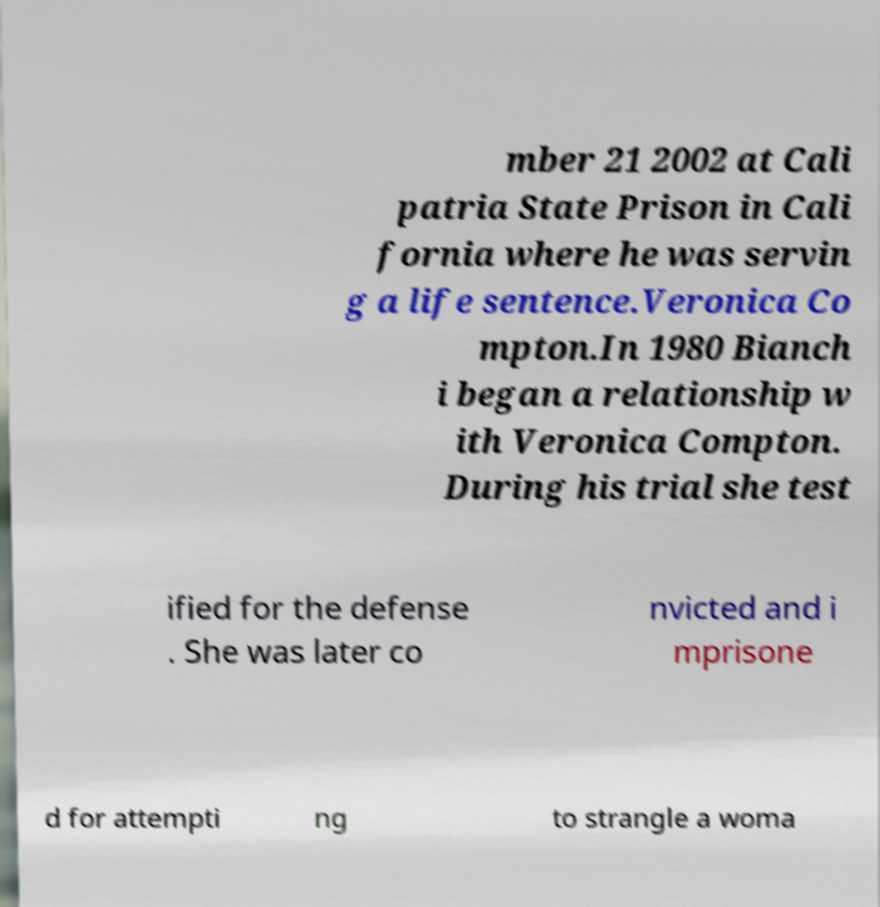What messages or text are displayed in this image? I need them in a readable, typed format. mber 21 2002 at Cali patria State Prison in Cali fornia where he was servin g a life sentence.Veronica Co mpton.In 1980 Bianch i began a relationship w ith Veronica Compton. During his trial she test ified for the defense . She was later co nvicted and i mprisone d for attempti ng to strangle a woma 